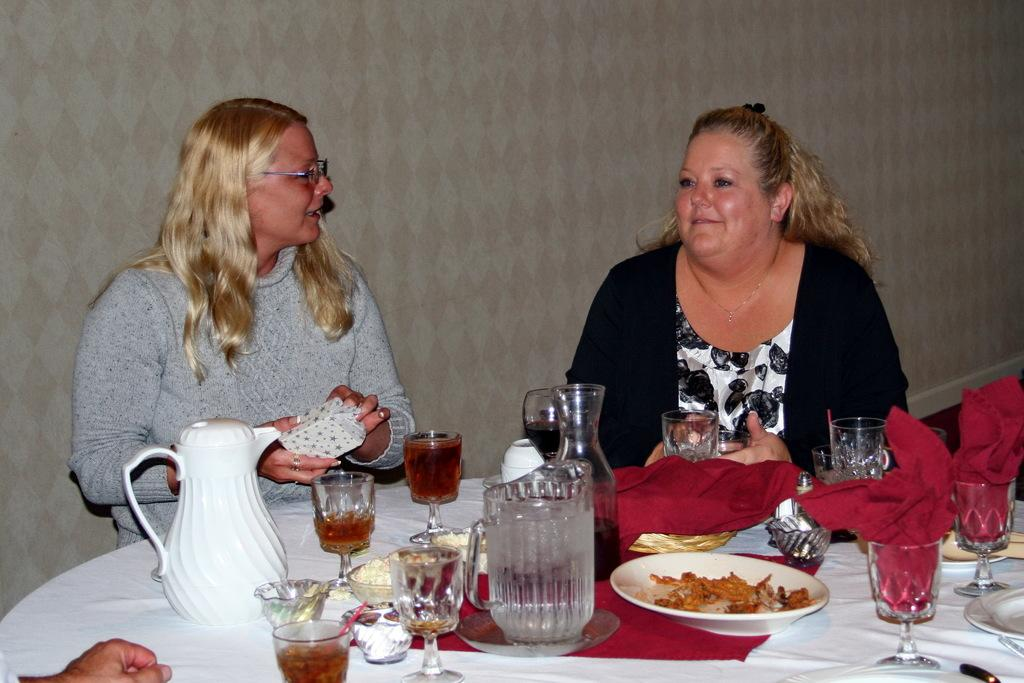How many people are sitting in the scene? There are two people sitting on chairs in the scene. What is in front of the chairs? There is a table in front of the chairs. What can be found on the table? There is a glass, plates, and other objects on the table. What is located at the back of the scene? There is a wall at the back of the scene. What is the purpose of the protest happening in the scene? There is no protest present in the scene; it only features two people sitting on chairs with a table and other objects. Can you tell me how many robins are perched on the wall in the scene? There are no robins present in the scene; the wall is at the back of the scene with no visible birds. 